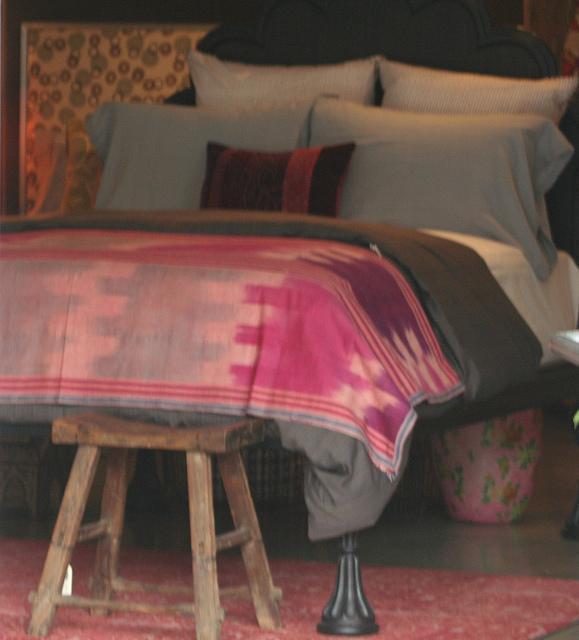How many pillows are on the bed?
Give a very brief answer. 5. How many people are holding a baseball bat?
Give a very brief answer. 0. 